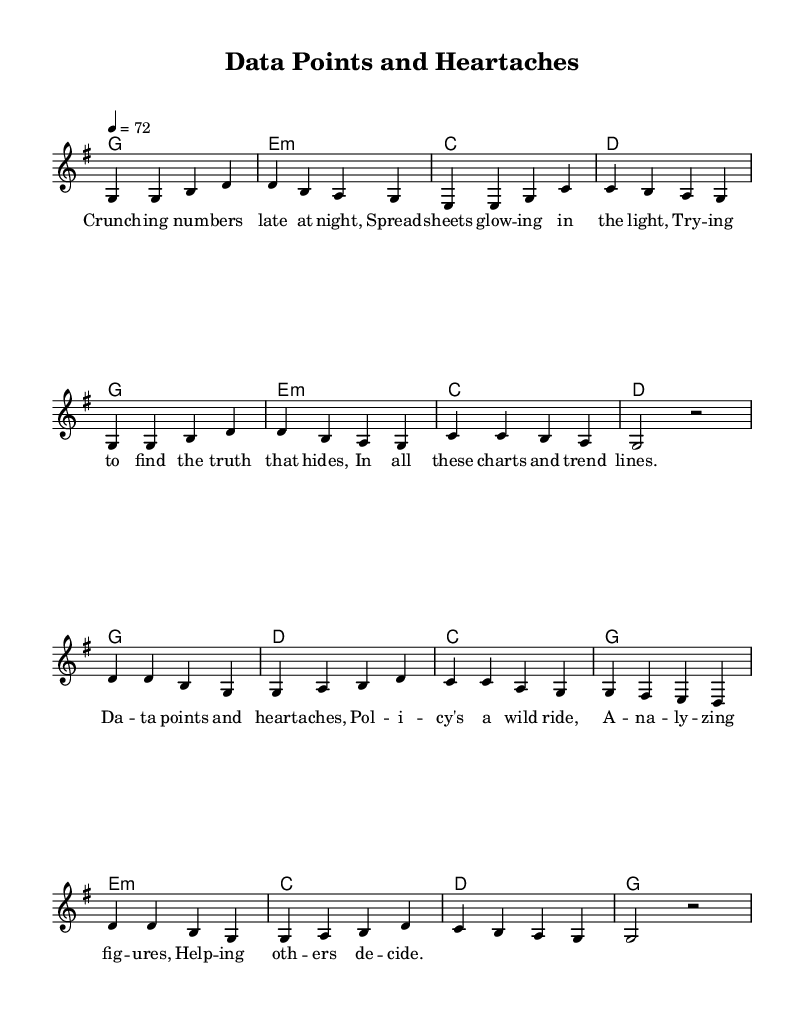What is the key signature of this music? The key signature indicated at the beginning of the score is G major, which has one sharp (F#).
Answer: G major What is the time signature of this music? The time signature shown in the score is 4/4, which means there are four beats in each measure and the quarter note gets one beat.
Answer: 4/4 What is the tempo marking of the piece? The tempo marking given is "4 = 72," suggesting a quarter note equals a tempo of 72 beats per minute.
Answer: 72 How many measures are in the verse section? Counting the measures written for the verse, there are eight measures in total before transitioning to the chorus.
Answer: 8 measures What chord is played on the first measure? The first measure of the piece indicates a G major chord, which is represented as 'g1' in the chord section.
Answer: G major What is the main theme of the chorus lyrics? The chorus lyrics revolve around the challenges of analyzing data and making decisions, encapsulated in the phrase "data points and heartaches."
Answer: Data points and heartaches How does the structure of this music reflect typical country ballads? This music features a clear verse and chorus structure, a common characteristic of country ballads, which often narrate personal or emotional stories.
Answer: Verse and chorus structure 